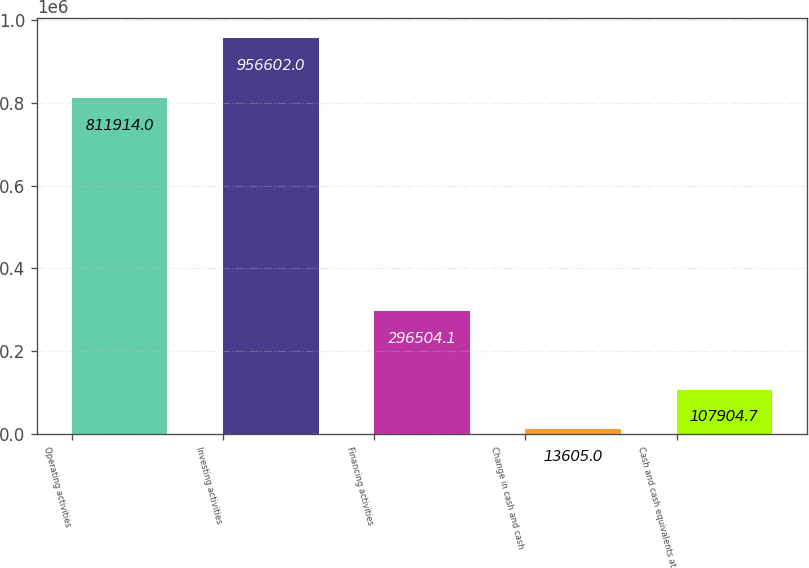<chart> <loc_0><loc_0><loc_500><loc_500><bar_chart><fcel>Operating activities<fcel>Investing activities<fcel>Financing activities<fcel>Change in cash and cash<fcel>Cash and cash equivalents at<nl><fcel>811914<fcel>956602<fcel>296504<fcel>13605<fcel>107905<nl></chart> 